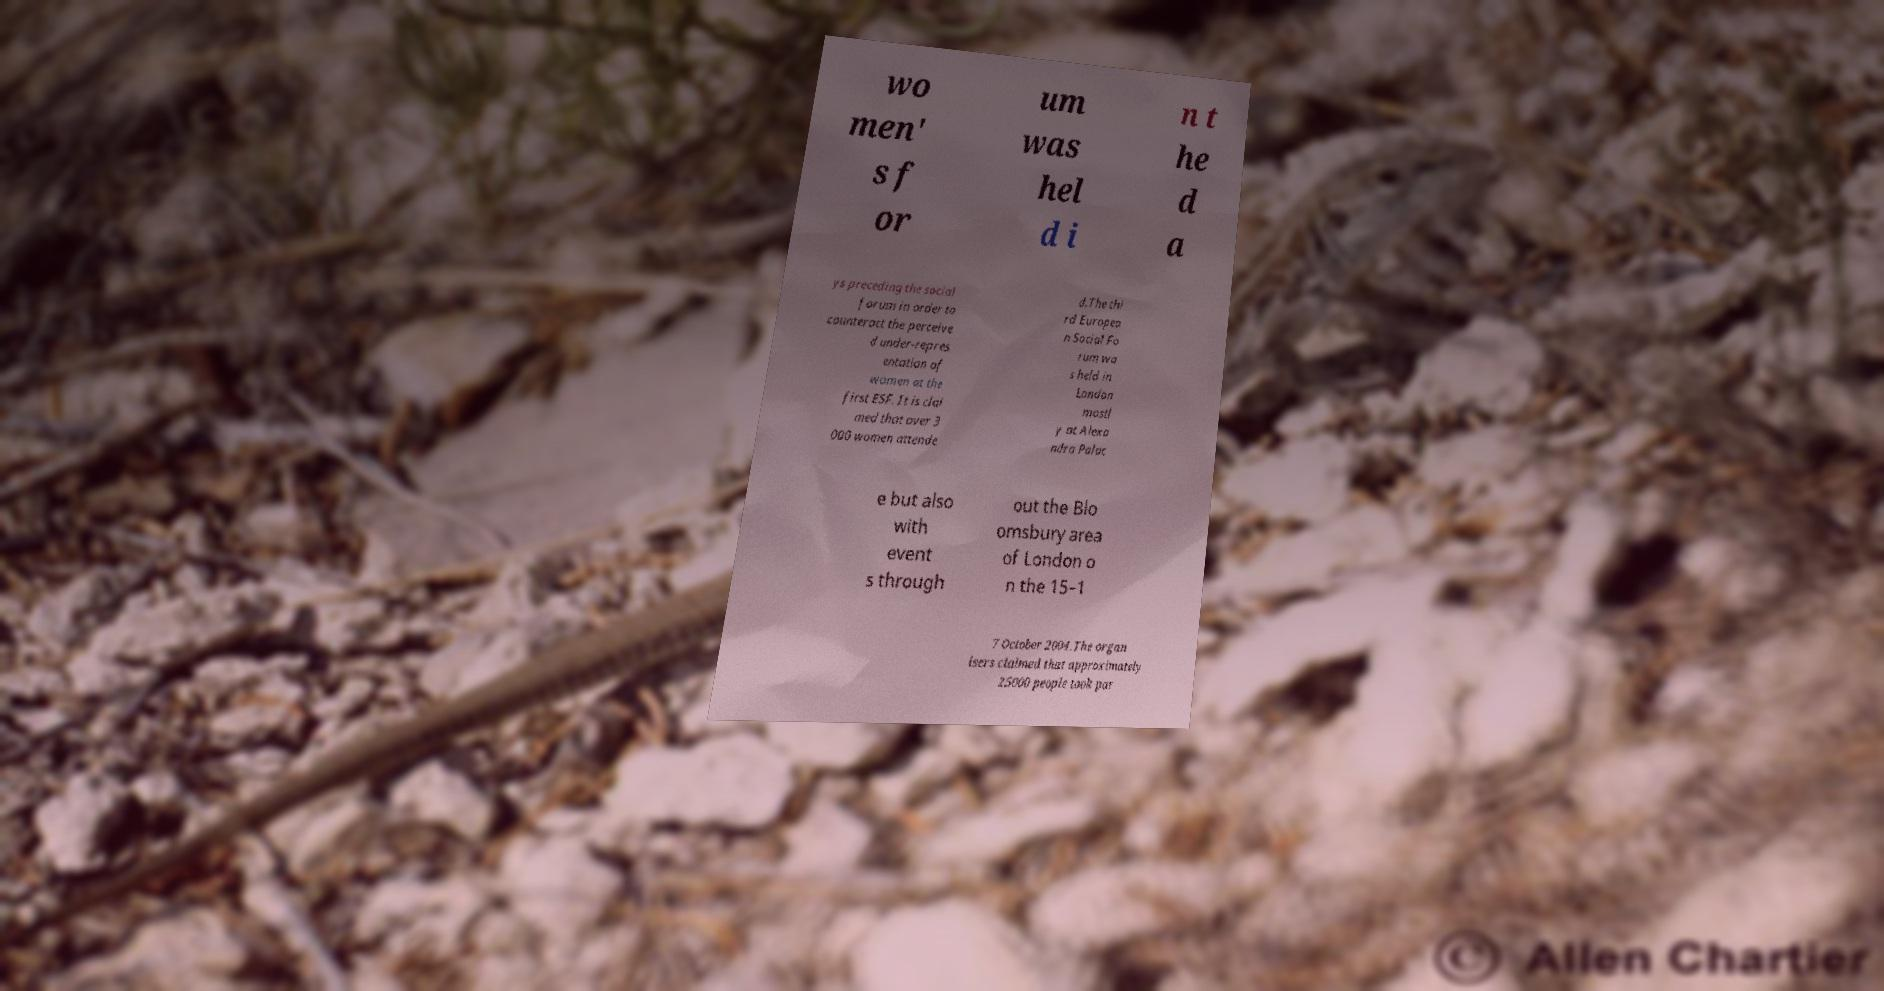For documentation purposes, I need the text within this image transcribed. Could you provide that? wo men' s f or um was hel d i n t he d a ys preceding the social forum in order to counteract the perceive d under-repres entation of women at the first ESF. It is clai med that over 3 000 women attende d.The thi rd Europea n Social Fo rum wa s held in London mostl y at Alexa ndra Palac e but also with event s through out the Blo omsbury area of London o n the 15–1 7 October 2004.The organ isers claimed that approximately 25000 people took par 